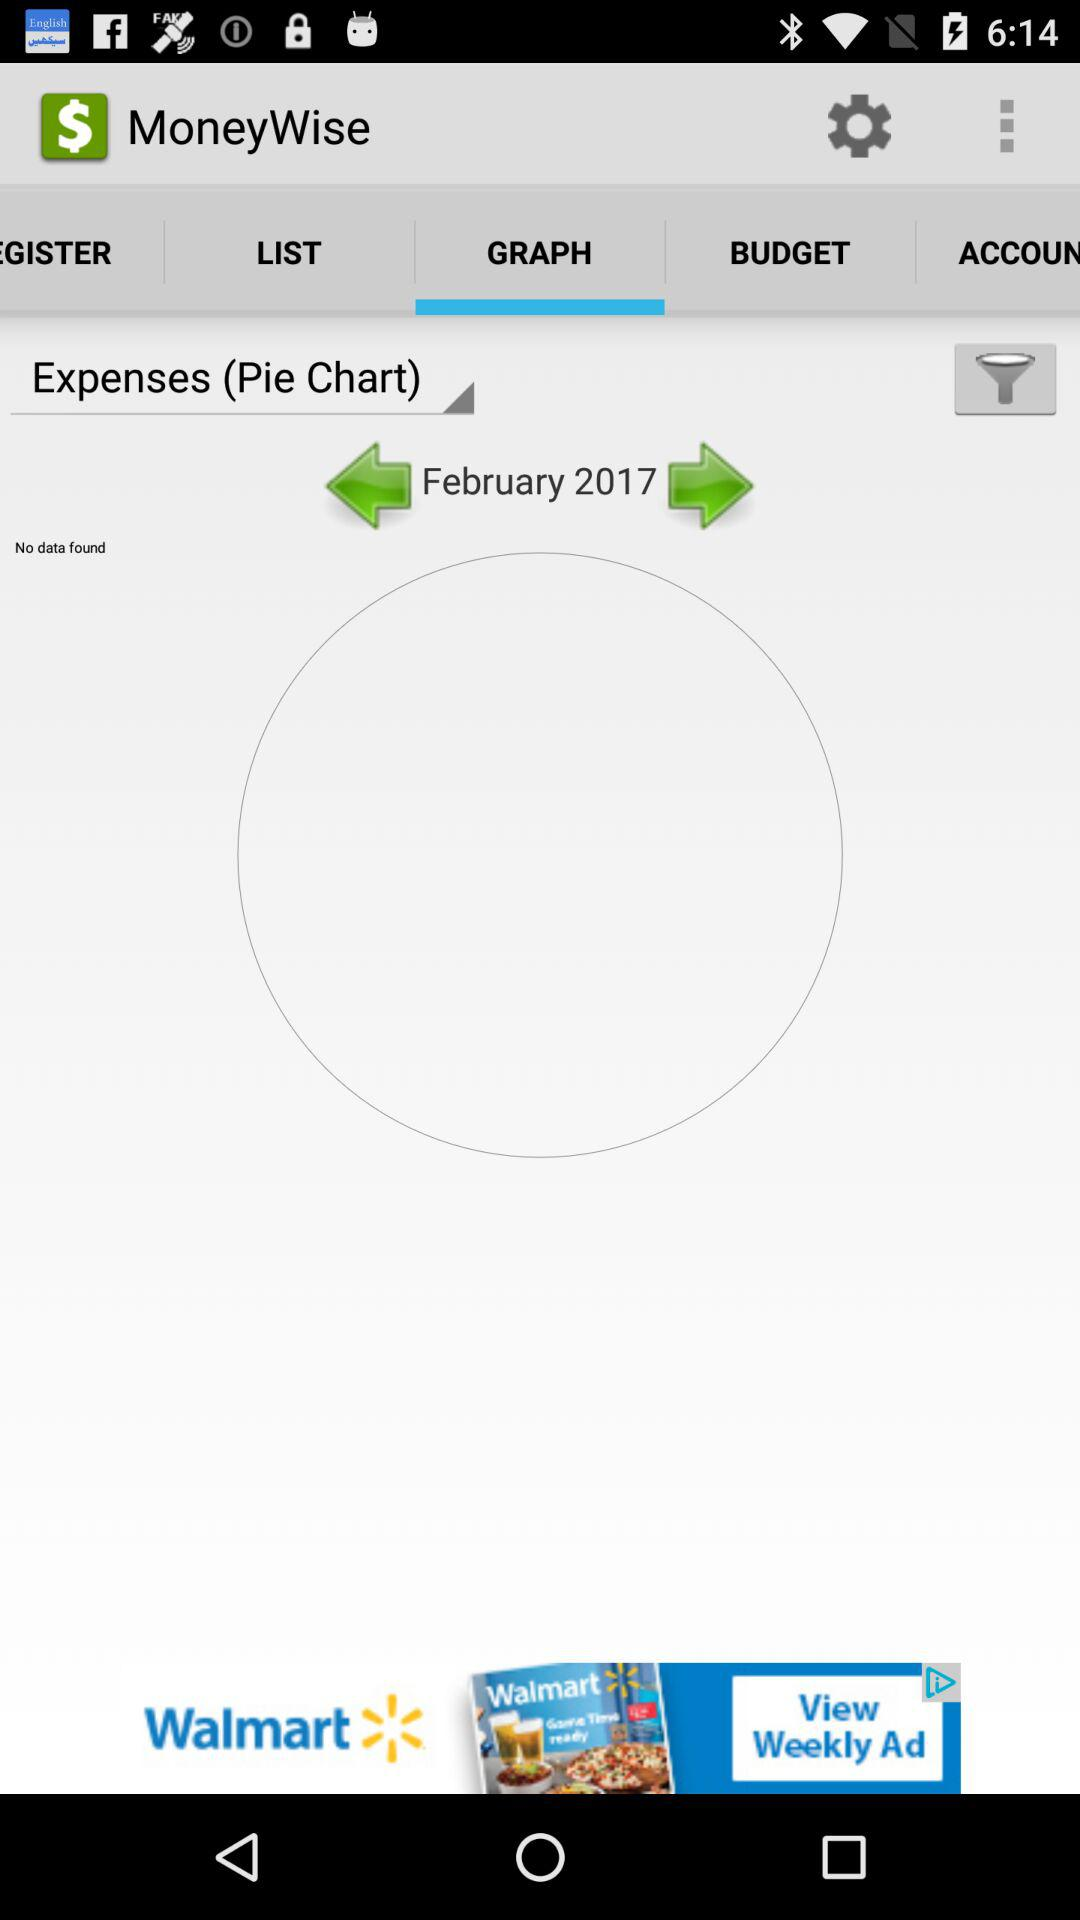What is the month and year selected? The selected month and year is February 2017. 